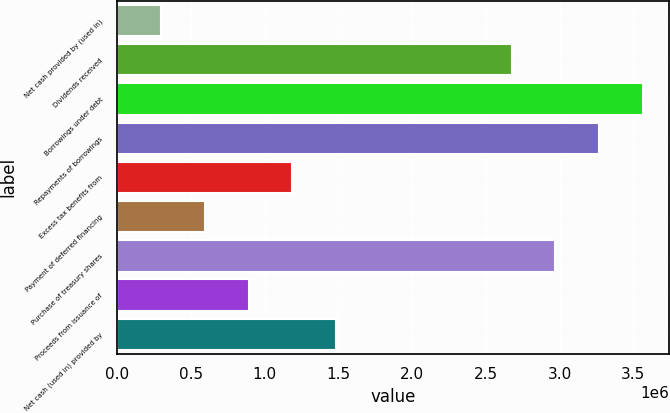<chart> <loc_0><loc_0><loc_500><loc_500><bar_chart><fcel>Net cash provided by (used in)<fcel>Dividends received<fcel>Borrowings under debt<fcel>Repayments of borrowings<fcel>Excess tax benefits from<fcel>Payment of deferred financing<fcel>Purchase of treasury shares<fcel>Proceeds from issuance of<fcel>Net cash (used in) provided by<nl><fcel>297582<fcel>2.67398e+06<fcel>3.56513e+06<fcel>3.26808e+06<fcel>1.18873e+06<fcel>594632<fcel>2.97103e+06<fcel>891681<fcel>1.48578e+06<nl></chart> 